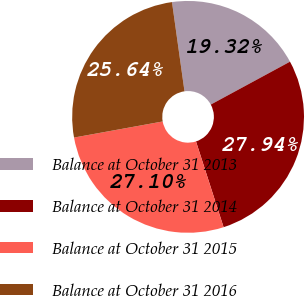Convert chart to OTSL. <chart><loc_0><loc_0><loc_500><loc_500><pie_chart><fcel>Balance at October 31 2013<fcel>Balance at October 31 2014<fcel>Balance at October 31 2015<fcel>Balance at October 31 2016<nl><fcel>19.32%<fcel>27.94%<fcel>27.1%<fcel>25.64%<nl></chart> 